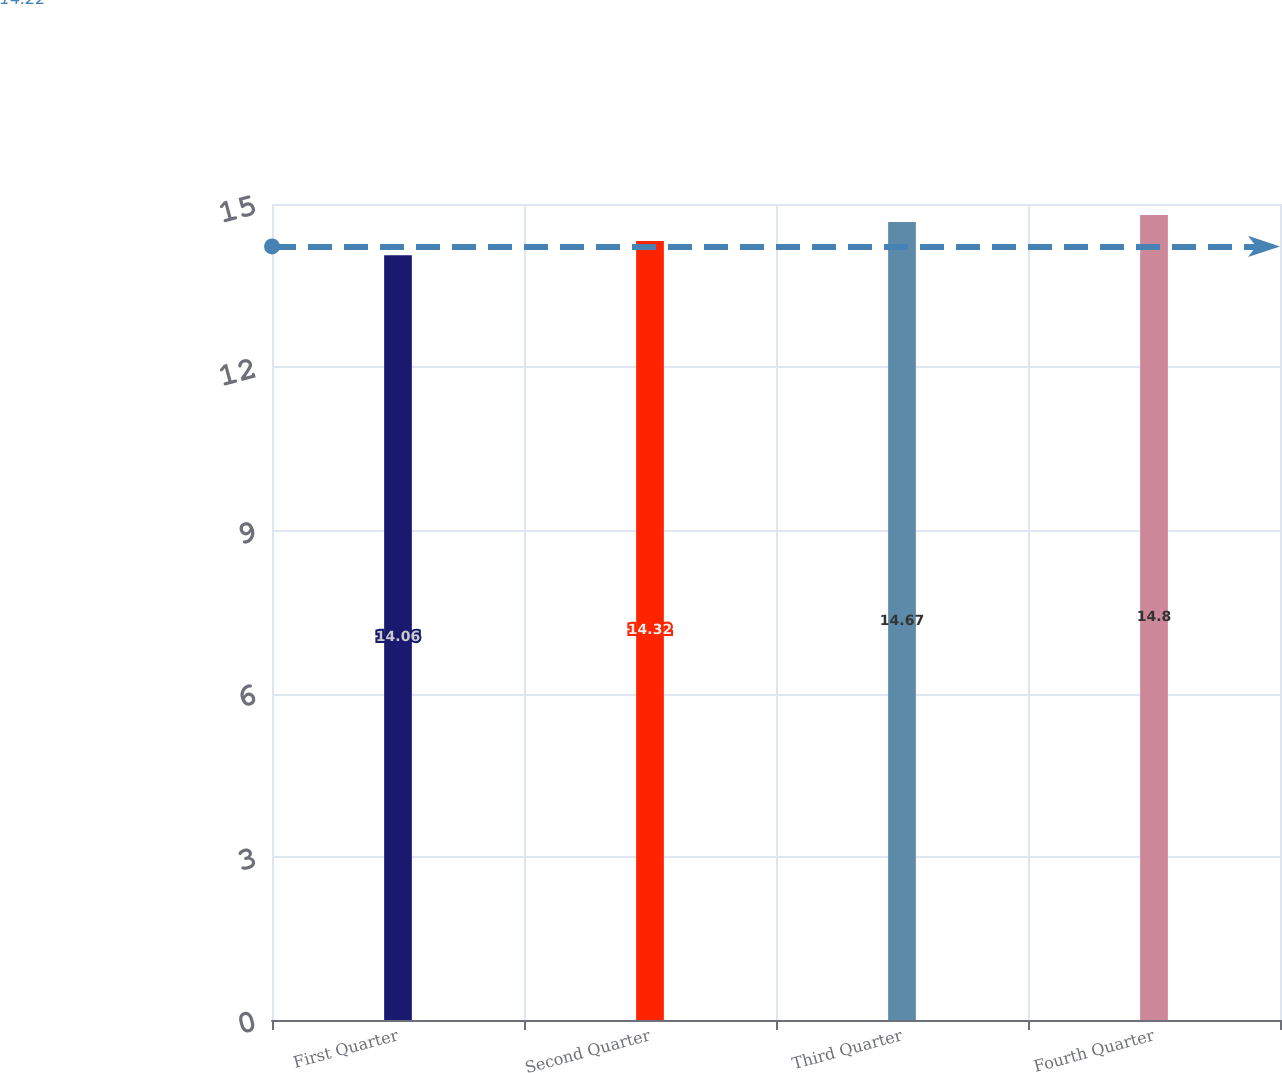<chart> <loc_0><loc_0><loc_500><loc_500><bar_chart><fcel>First Quarter<fcel>Second Quarter<fcel>Third Quarter<fcel>Fourth Quarter<nl><fcel>14.06<fcel>14.32<fcel>14.67<fcel>14.8<nl></chart> 